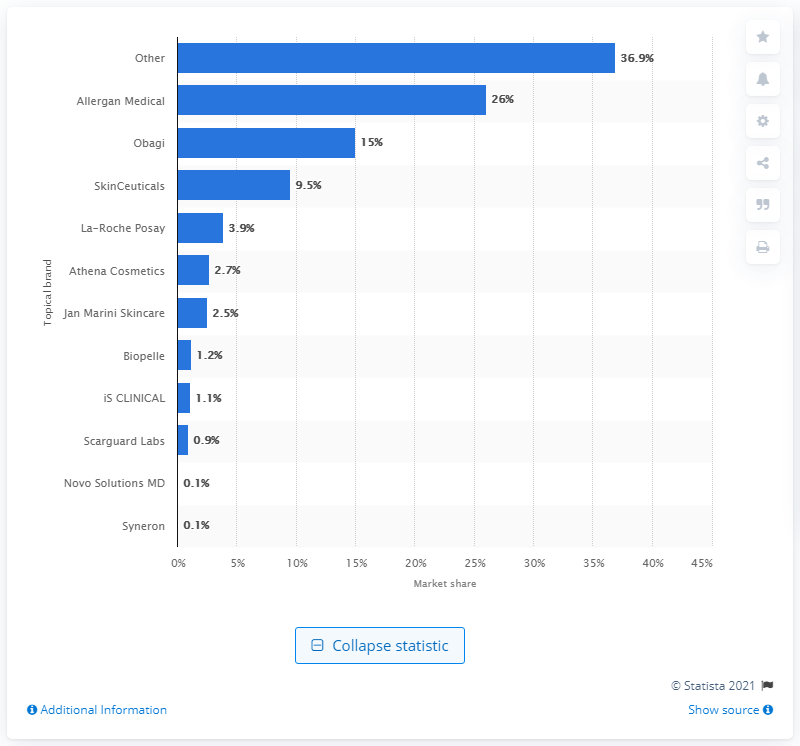Draw attention to some important aspects in this diagram. Allergan Medical was the most popular topical brand in the US in 2012. 